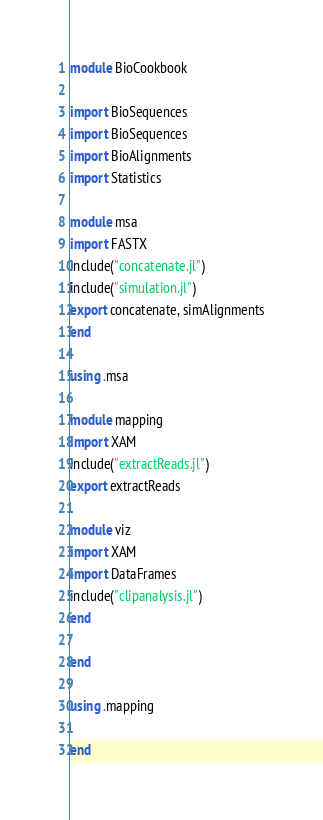<code> <loc_0><loc_0><loc_500><loc_500><_Julia_>module BioCookbook

import BioSequences
import BioSequences
import BioAlignments
import Statistics

module msa
import FASTX
include("concatenate.jl")
include("simulation.jl")
export concatenate, simAlignments
end

using .msa

module mapping
import XAM
include("extractReads.jl")
export extractReads

module viz
import XAM
import DataFrames
include("clipanalysis.jl")
end

end

using .mapping

end</code> 